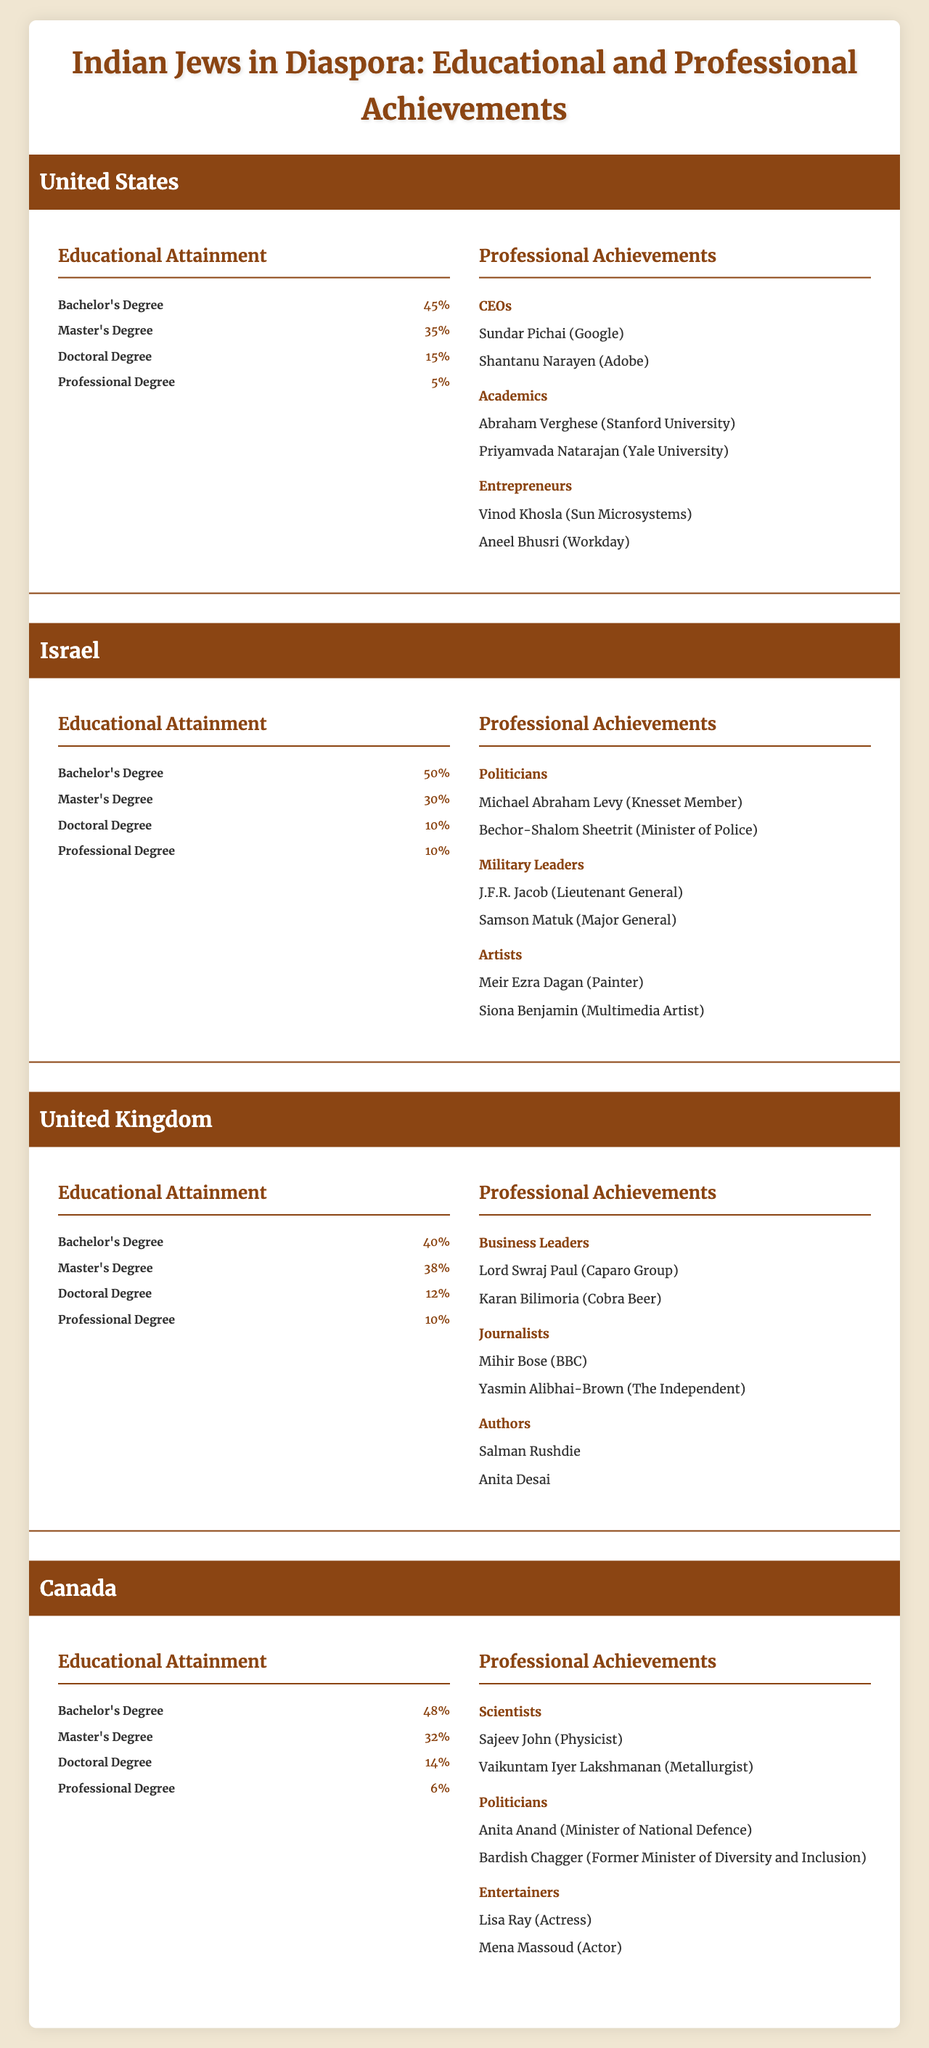What is the percentage of Indian Jews in the United States who hold a Master's Degree? Looking at the table, the educational attainment for the United States shows that 35% of Indian Jews have a Master's Degree.
Answer: 35% Which diaspora location has the highest percentage of Indian Jews with a Bachelor's Degree? Comparing the percentage of Bachelor's Degrees across all locations, Israel has the highest at 50%.
Answer: Israel How many CEOs from Indian Jews are listed in the United States? The United States has 2 listed CEOs: Sundar Pichai and Shantanu Narayen.
Answer: 2 What is the total percentage of Indian Jews in Canada with either a Master's Degree or a Doctoral Degree? In Canada, 32% have a Master's Degree and 14% have a Doctoral Degree. Therefore, the total is 32% + 14% = 46%.
Answer: 46% In which diaspora location do Indian Jews have the lowest percentage of Professional Degrees? The United States has the lowest percentage of Professional Degrees at 5%.
Answer: United States Are there any Indian Jewish artists listed in Israel? Yes, Siona Benjamin and Meir Ezra Dagan are noted as artists in Israel.
Answer: Yes What is the difference in percentage of Master's Degrees between Indian Jews in the United States and the United Kingdom? The United States has 35% and the United Kingdom has 38% with Master's Degrees. The difference is 38% - 35% = 3%.
Answer: 3% Calculate the average percentage of Doctoral Degrees among Indian Jews in all diaspora locations. The percentages are 15% (US), 10% (Israel), 12% (UK), and 14% (Canada). The average is (15 + 10 + 12 + 14) / 4 = 51 / 4 = 12.75%.
Answer: 12.75% Which category of professionals has the highest representation in Canada? In Canada, the Scientists category has 2 individuals listed, which indicates a strong representation compared to other categories like Politicians and Entertainers also having 2 but are more varied.
Answer: Scientists Is it true that no Indian Jews in the United Kingdom are authors? False, because both Salman Rushdie and Anita Desai are listed as authors from the United Kingdom.
Answer: False How does the percentage of Doctoral Degrees in Israel compare to that in Canada? Israel has 10% of Indian Jews with Doctoral Degrees, while Canada has 14%. Thus, Canada has a higher percentage by 4%.
Answer: Canada has a higher percentage by 4% 